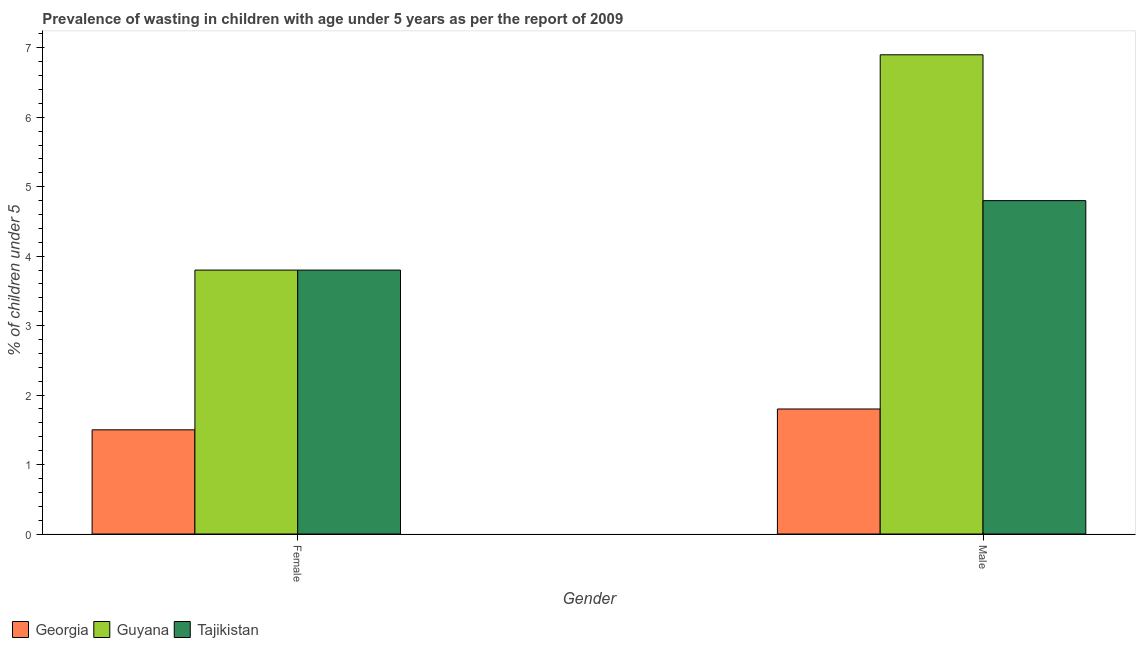How many groups of bars are there?
Ensure brevity in your answer.  2. Are the number of bars per tick equal to the number of legend labels?
Offer a very short reply. Yes. How many bars are there on the 2nd tick from the left?
Offer a very short reply. 3. How many bars are there on the 2nd tick from the right?
Provide a short and direct response. 3. What is the percentage of undernourished female children in Tajikistan?
Provide a succinct answer. 3.8. Across all countries, what is the maximum percentage of undernourished male children?
Ensure brevity in your answer.  6.9. In which country was the percentage of undernourished male children maximum?
Keep it short and to the point. Guyana. In which country was the percentage of undernourished male children minimum?
Give a very brief answer. Georgia. What is the total percentage of undernourished female children in the graph?
Keep it short and to the point. 9.1. What is the difference between the percentage of undernourished female children in Georgia and that in Guyana?
Your answer should be compact. -2.3. What is the average percentage of undernourished male children per country?
Your answer should be compact. 4.5. What is the difference between the percentage of undernourished male children and percentage of undernourished female children in Tajikistan?
Offer a terse response. 1. What is the ratio of the percentage of undernourished male children in Tajikistan to that in Guyana?
Offer a terse response. 0.7. What does the 2nd bar from the left in Male represents?
Your answer should be compact. Guyana. What does the 1st bar from the right in Female represents?
Ensure brevity in your answer.  Tajikistan. Are all the bars in the graph horizontal?
Provide a short and direct response. No. How many countries are there in the graph?
Your answer should be compact. 3. Are the values on the major ticks of Y-axis written in scientific E-notation?
Make the answer very short. No. Does the graph contain any zero values?
Your response must be concise. No. Does the graph contain grids?
Your answer should be compact. No. Where does the legend appear in the graph?
Offer a terse response. Bottom left. How are the legend labels stacked?
Your response must be concise. Horizontal. What is the title of the graph?
Make the answer very short. Prevalence of wasting in children with age under 5 years as per the report of 2009. Does "Colombia" appear as one of the legend labels in the graph?
Make the answer very short. No. What is the label or title of the Y-axis?
Keep it short and to the point.  % of children under 5. What is the  % of children under 5 of Georgia in Female?
Your response must be concise. 1.5. What is the  % of children under 5 in Guyana in Female?
Keep it short and to the point. 3.8. What is the  % of children under 5 in Tajikistan in Female?
Ensure brevity in your answer.  3.8. What is the  % of children under 5 in Georgia in Male?
Keep it short and to the point. 1.8. What is the  % of children under 5 of Guyana in Male?
Give a very brief answer. 6.9. What is the  % of children under 5 in Tajikistan in Male?
Make the answer very short. 4.8. Across all Gender, what is the maximum  % of children under 5 in Georgia?
Your answer should be compact. 1.8. Across all Gender, what is the maximum  % of children under 5 of Guyana?
Give a very brief answer. 6.9. Across all Gender, what is the maximum  % of children under 5 in Tajikistan?
Keep it short and to the point. 4.8. Across all Gender, what is the minimum  % of children under 5 in Guyana?
Provide a succinct answer. 3.8. Across all Gender, what is the minimum  % of children under 5 in Tajikistan?
Offer a very short reply. 3.8. What is the difference between the  % of children under 5 of Georgia in Female and that in Male?
Provide a short and direct response. -0.3. What is the difference between the  % of children under 5 of Tajikistan in Female and that in Male?
Your answer should be compact. -1. What is the difference between the  % of children under 5 in Georgia in Female and the  % of children under 5 in Tajikistan in Male?
Offer a very short reply. -3.3. What is the average  % of children under 5 of Georgia per Gender?
Provide a succinct answer. 1.65. What is the average  % of children under 5 in Guyana per Gender?
Offer a very short reply. 5.35. What is the difference between the  % of children under 5 in Georgia and  % of children under 5 in Guyana in Female?
Keep it short and to the point. -2.3. What is the difference between the  % of children under 5 in Georgia and  % of children under 5 in Tajikistan in Female?
Offer a terse response. -2.3. What is the difference between the  % of children under 5 of Guyana and  % of children under 5 of Tajikistan in Female?
Make the answer very short. 0. What is the difference between the  % of children under 5 in Georgia and  % of children under 5 in Tajikistan in Male?
Offer a very short reply. -3. What is the ratio of the  % of children under 5 in Georgia in Female to that in Male?
Offer a terse response. 0.83. What is the ratio of the  % of children under 5 in Guyana in Female to that in Male?
Offer a terse response. 0.55. What is the ratio of the  % of children under 5 in Tajikistan in Female to that in Male?
Your answer should be compact. 0.79. What is the difference between the highest and the second highest  % of children under 5 in Georgia?
Your answer should be very brief. 0.3. What is the difference between the highest and the lowest  % of children under 5 in Guyana?
Offer a very short reply. 3.1. What is the difference between the highest and the lowest  % of children under 5 of Tajikistan?
Your answer should be compact. 1. 